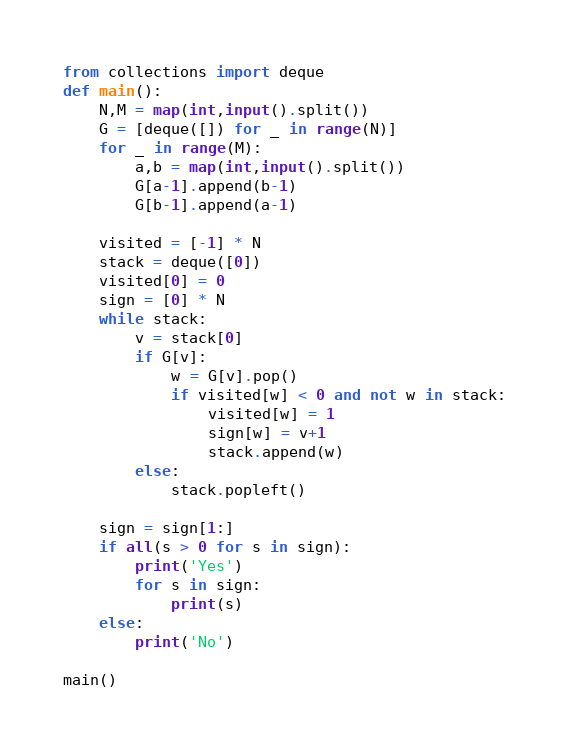Convert code to text. <code><loc_0><loc_0><loc_500><loc_500><_Python_>from collections import deque
def main():
    N,M = map(int,input().split())
    G = [deque([]) for _ in range(N)]
    for _ in range(M):
        a,b = map(int,input().split())
        G[a-1].append(b-1)
        G[b-1].append(a-1)

    visited = [-1] * N
    stack = deque([0])
    visited[0] = 0
    sign = [0] * N
    while stack:
        v = stack[0]
        if G[v]:
            w = G[v].pop()
            if visited[w] < 0 and not w in stack:
                visited[w] = 1
                sign[w] = v+1
                stack.append(w)
        else:
            stack.popleft()

    sign = sign[1:]
    if all(s > 0 for s in sign):
        print('Yes')
        for s in sign:
            print(s)
    else:
        print('No')
        
main()</code> 